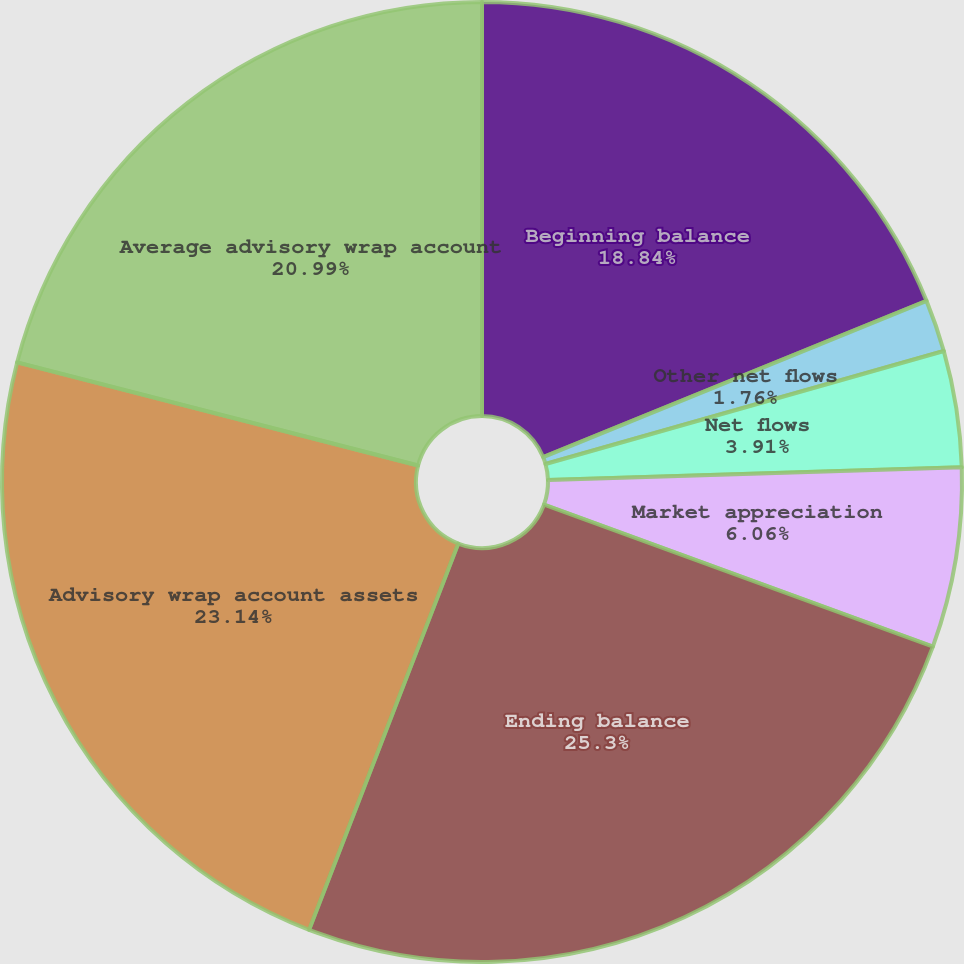Convert chart to OTSL. <chart><loc_0><loc_0><loc_500><loc_500><pie_chart><fcel>Beginning balance<fcel>Other net flows<fcel>Net flows<fcel>Market appreciation<fcel>Ending balance<fcel>Advisory wrap account assets<fcel>Average advisory wrap account<nl><fcel>18.84%<fcel>1.76%<fcel>3.91%<fcel>6.06%<fcel>25.29%<fcel>23.14%<fcel>20.99%<nl></chart> 